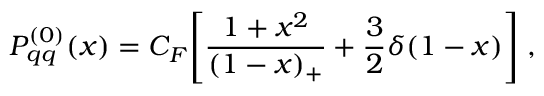Convert formula to latex. <formula><loc_0><loc_0><loc_500><loc_500>P _ { q q } ^ { ( 0 ) } ( x ) = C _ { F } \left [ \frac { 1 + x ^ { 2 } } { ( 1 - x ) _ { + } } + \frac { 3 } { 2 } \delta ( 1 - x ) \right ] \, ,</formula> 